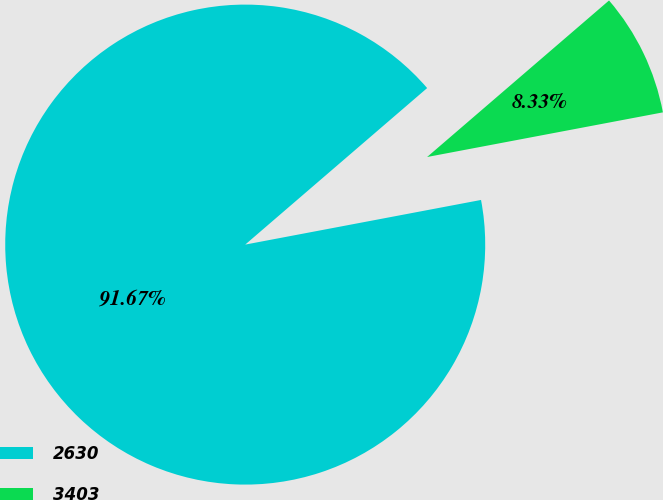<chart> <loc_0><loc_0><loc_500><loc_500><pie_chart><fcel>2630<fcel>3403<nl><fcel>91.67%<fcel>8.33%<nl></chart> 